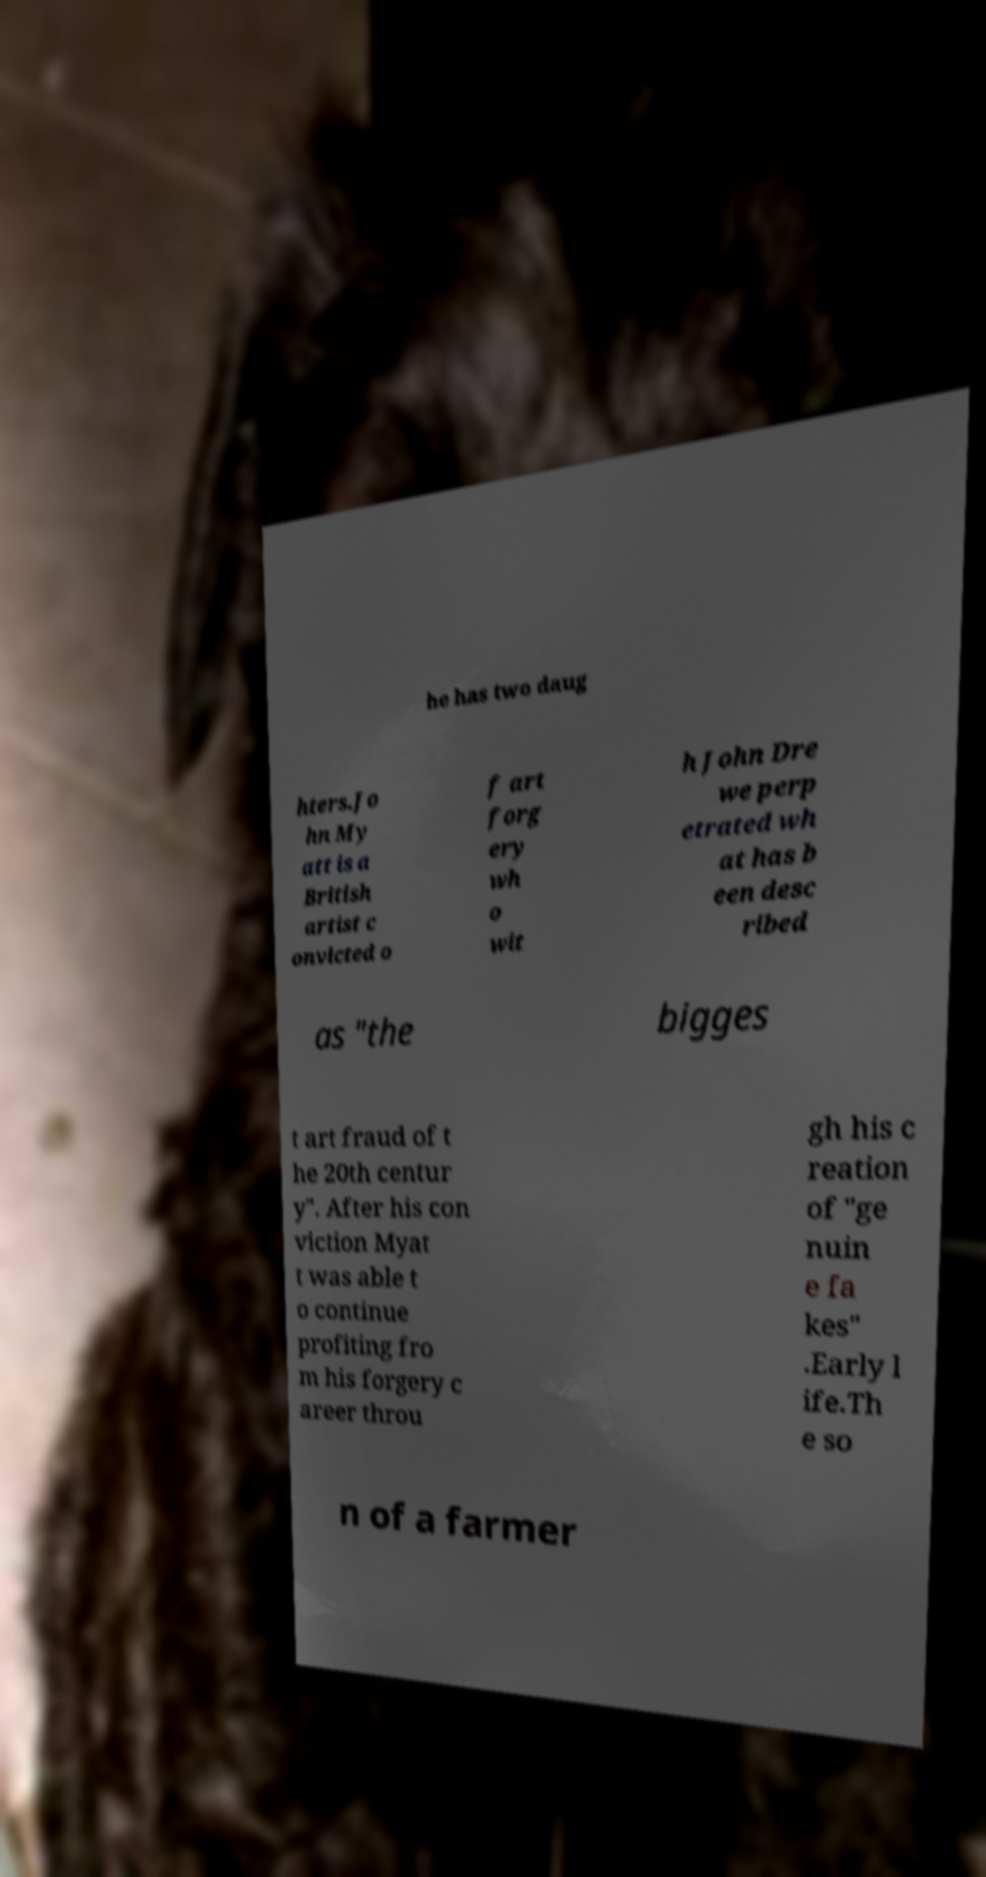Could you extract and type out the text from this image? he has two daug hters.Jo hn My att is a British artist c onvicted o f art forg ery wh o wit h John Dre we perp etrated wh at has b een desc ribed as "the bigges t art fraud of t he 20th centur y". After his con viction Myat t was able t o continue profiting fro m his forgery c areer throu gh his c reation of "ge nuin e fa kes" .Early l ife.Th e so n of a farmer 